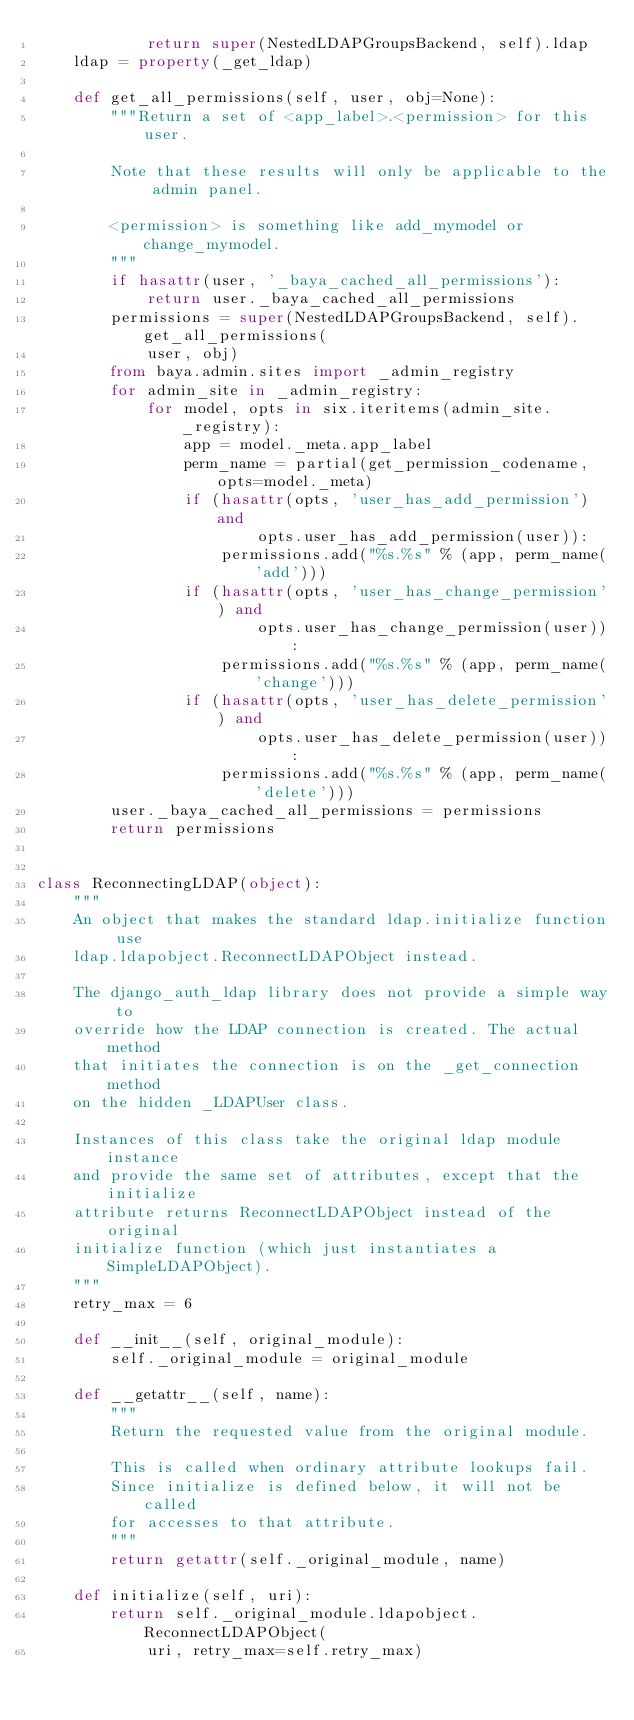Convert code to text. <code><loc_0><loc_0><loc_500><loc_500><_Python_>            return super(NestedLDAPGroupsBackend, self).ldap
    ldap = property(_get_ldap)

    def get_all_permissions(self, user, obj=None):
        """Return a set of <app_label>.<permission> for this user.

        Note that these results will only be applicable to the admin panel.

        <permission> is something like add_mymodel or change_mymodel.
        """
        if hasattr(user, '_baya_cached_all_permissions'):
            return user._baya_cached_all_permissions
        permissions = super(NestedLDAPGroupsBackend, self).get_all_permissions(
            user, obj)
        from baya.admin.sites import _admin_registry
        for admin_site in _admin_registry:
            for model, opts in six.iteritems(admin_site._registry):
                app = model._meta.app_label
                perm_name = partial(get_permission_codename, opts=model._meta)
                if (hasattr(opts, 'user_has_add_permission') and
                        opts.user_has_add_permission(user)):
                    permissions.add("%s.%s" % (app, perm_name('add')))
                if (hasattr(opts, 'user_has_change_permission') and
                        opts.user_has_change_permission(user)):
                    permissions.add("%s.%s" % (app, perm_name('change')))
                if (hasattr(opts, 'user_has_delete_permission') and
                        opts.user_has_delete_permission(user)):
                    permissions.add("%s.%s" % (app, perm_name('delete')))
        user._baya_cached_all_permissions = permissions
        return permissions


class ReconnectingLDAP(object):
    """
    An object that makes the standard ldap.initialize function use
    ldap.ldapobject.ReconnectLDAPObject instead.

    The django_auth_ldap library does not provide a simple way to
    override how the LDAP connection is created. The actual method
    that initiates the connection is on the _get_connection method
    on the hidden _LDAPUser class.

    Instances of this class take the original ldap module instance
    and provide the same set of attributes, except that the initialize
    attribute returns ReconnectLDAPObject instead of the original
    initialize function (which just instantiates a SimpleLDAPObject).
    """
    retry_max = 6

    def __init__(self, original_module):
        self._original_module = original_module

    def __getattr__(self, name):
        """
        Return the requested value from the original module.

        This is called when ordinary attribute lookups fail.
        Since initialize is defined below, it will not be called
        for accesses to that attribute.
        """
        return getattr(self._original_module, name)

    def initialize(self, uri):
        return self._original_module.ldapobject.ReconnectLDAPObject(
            uri, retry_max=self.retry_max)
</code> 